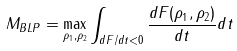<formula> <loc_0><loc_0><loc_500><loc_500>M _ { B L P } = \max _ { \rho _ { 1 } , \rho _ { 2 } } \int _ { d F / d t < 0 } \frac { d F ( \rho _ { 1 } , \rho _ { 2 } ) } { d t } d t</formula> 